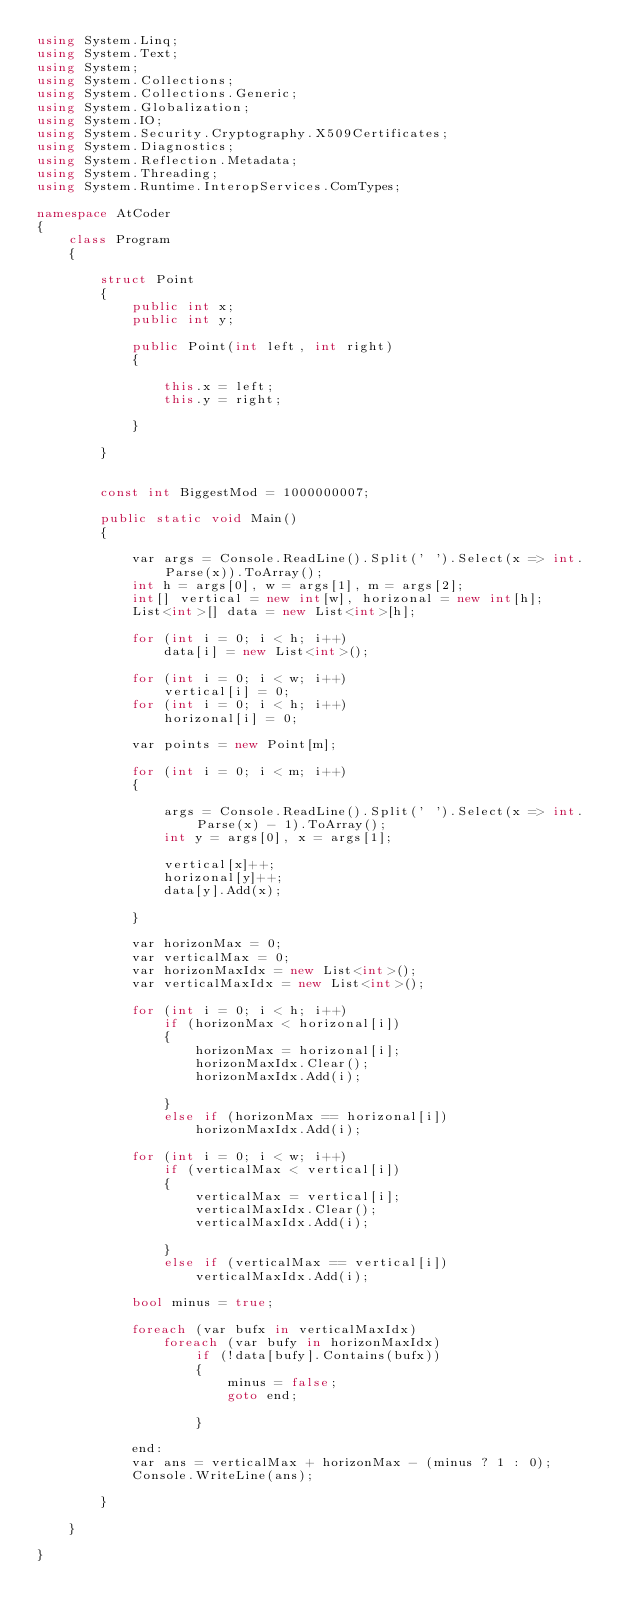Convert code to text. <code><loc_0><loc_0><loc_500><loc_500><_C#_>using System.Linq;
using System.Text;
using System;
using System.Collections;
using System.Collections.Generic;
using System.Globalization;
using System.IO;
using System.Security.Cryptography.X509Certificates;
using System.Diagnostics;
using System.Reflection.Metadata;
using System.Threading;
using System.Runtime.InteropServices.ComTypes;

namespace AtCoder
{
    class Program
    {

        struct Point
        {
            public int x;
            public int y;

            public Point(int left, int right)
            {

                this.x = left;
                this.y = right;

            }

        }


        const int BiggestMod = 1000000007;

        public static void Main()
        {

            var args = Console.ReadLine().Split(' ').Select(x => int.Parse(x)).ToArray();
            int h = args[0], w = args[1], m = args[2];
            int[] vertical = new int[w], horizonal = new int[h];
            List<int>[] data = new List<int>[h];

            for (int i = 0; i < h; i++)
                data[i] = new List<int>();

            for (int i = 0; i < w; i++)
                vertical[i] = 0;
            for (int i = 0; i < h; i++)
                horizonal[i] = 0;

            var points = new Point[m];

            for (int i = 0; i < m; i++)
            {

                args = Console.ReadLine().Split(' ').Select(x => int.Parse(x) - 1).ToArray();
                int y = args[0], x = args[1];

                vertical[x]++;
                horizonal[y]++;
                data[y].Add(x);

            }

            var horizonMax = 0;
            var verticalMax = 0;
            var horizonMaxIdx = new List<int>();
            var verticalMaxIdx = new List<int>();

            for (int i = 0; i < h; i++)
                if (horizonMax < horizonal[i])
                {
                    horizonMax = horizonal[i];
                    horizonMaxIdx.Clear();
                    horizonMaxIdx.Add(i);

                }
                else if (horizonMax == horizonal[i])
                    horizonMaxIdx.Add(i);

            for (int i = 0; i < w; i++)
                if (verticalMax < vertical[i])
                {
                    verticalMax = vertical[i];
                    verticalMaxIdx.Clear();
                    verticalMaxIdx.Add(i);

                }
                else if (verticalMax == vertical[i])
                    verticalMaxIdx.Add(i);

            bool minus = true;

            foreach (var bufx in verticalMaxIdx)
                foreach (var bufy in horizonMaxIdx)
                    if (!data[bufy].Contains(bufx))
                    {
                        minus = false;
                        goto end;

                    }

            end:
            var ans = verticalMax + horizonMax - (minus ? 1 : 0);
            Console.WriteLine(ans);

        }

    }

}</code> 